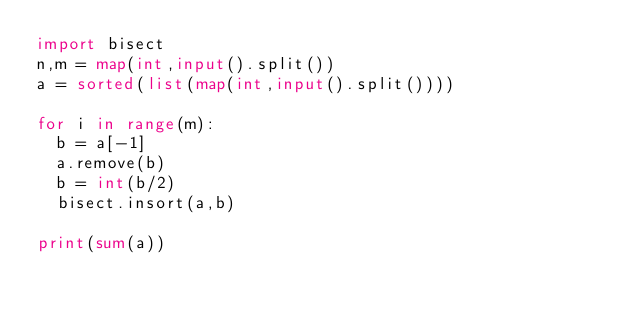<code> <loc_0><loc_0><loc_500><loc_500><_Python_>import bisect 
n,m = map(int,input().split())
a = sorted(list(map(int,input().split())))
 
for i in range(m):
  b = a[-1]
  a.remove(b)
  b = int(b/2)
  bisect.insort(a,b)
  
print(sum(a))</code> 